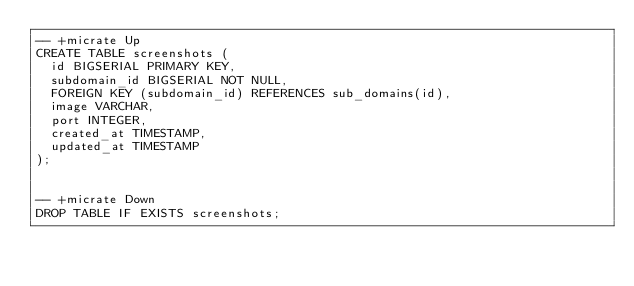Convert code to text. <code><loc_0><loc_0><loc_500><loc_500><_SQL_>-- +micrate Up
CREATE TABLE screenshots (
  id BIGSERIAL PRIMARY KEY,
  subdomain_id BIGSERIAL NOT NULL,
  FOREIGN KEY (subdomain_id) REFERENCES sub_domains(id),
  image VARCHAR,
  port INTEGER,
  created_at TIMESTAMP,
  updated_at TIMESTAMP
);


-- +micrate Down
DROP TABLE IF EXISTS screenshots;
</code> 